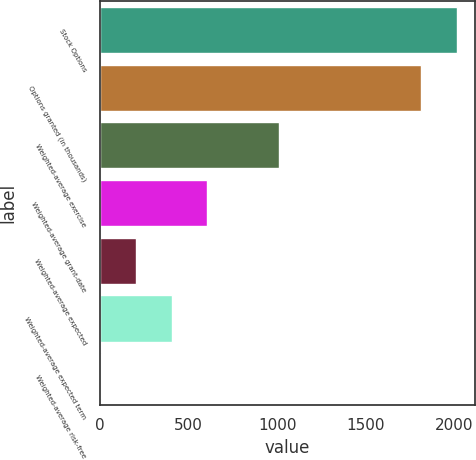Convert chart to OTSL. <chart><loc_0><loc_0><loc_500><loc_500><bar_chart><fcel>Stock Options<fcel>Options granted (in thousands)<fcel>Weighted-average exercise<fcel>Weighted-average grant-date<fcel>Weighted-average expected<fcel>Weighted-average expected term<fcel>Weighted-average risk-free<nl><fcel>2016<fcel>1814<fcel>1008.7<fcel>605.78<fcel>202.86<fcel>404.32<fcel>1.4<nl></chart> 